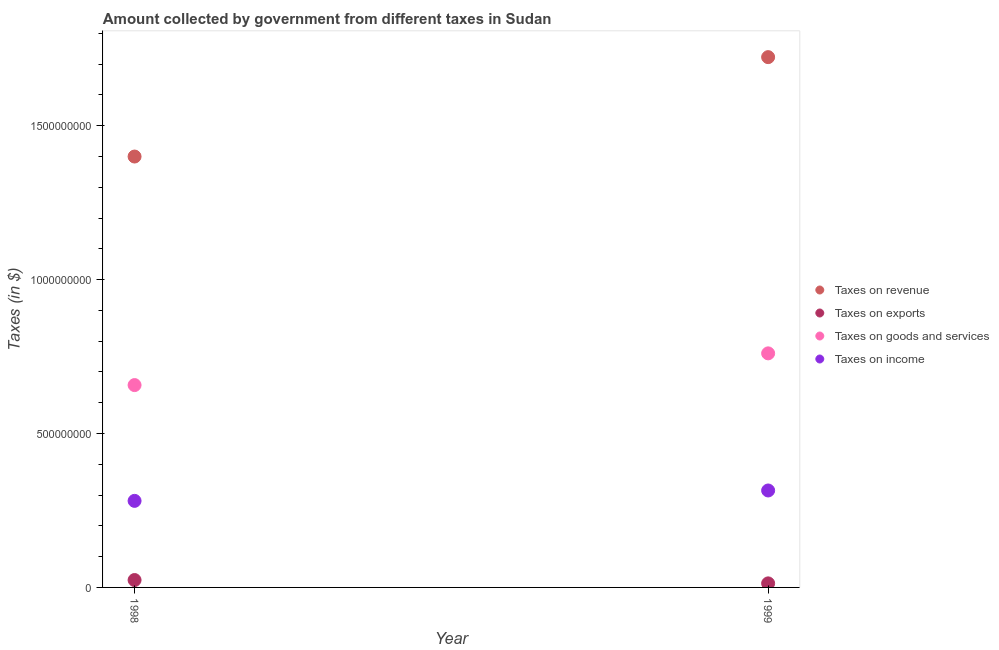Is the number of dotlines equal to the number of legend labels?
Offer a terse response. Yes. What is the amount collected as tax on exports in 1999?
Offer a terse response. 1.32e+07. Across all years, what is the maximum amount collected as tax on goods?
Your response must be concise. 7.60e+08. Across all years, what is the minimum amount collected as tax on exports?
Your answer should be very brief. 1.32e+07. In which year was the amount collected as tax on exports minimum?
Provide a succinct answer. 1999. What is the total amount collected as tax on income in the graph?
Your answer should be compact. 5.96e+08. What is the difference between the amount collected as tax on income in 1998 and that in 1999?
Offer a very short reply. -3.38e+07. What is the difference between the amount collected as tax on goods in 1999 and the amount collected as tax on exports in 1998?
Offer a terse response. 7.36e+08. What is the average amount collected as tax on goods per year?
Give a very brief answer. 7.09e+08. In the year 1998, what is the difference between the amount collected as tax on revenue and amount collected as tax on goods?
Provide a succinct answer. 7.43e+08. In how many years, is the amount collected as tax on income greater than 800000000 $?
Offer a terse response. 0. What is the ratio of the amount collected as tax on goods in 1998 to that in 1999?
Give a very brief answer. 0.86. Is the amount collected as tax on goods in 1998 less than that in 1999?
Your answer should be very brief. Yes. Is it the case that in every year, the sum of the amount collected as tax on exports and amount collected as tax on income is greater than the sum of amount collected as tax on revenue and amount collected as tax on goods?
Provide a short and direct response. No. Does the amount collected as tax on exports monotonically increase over the years?
Make the answer very short. No. How many years are there in the graph?
Provide a short and direct response. 2. What is the difference between two consecutive major ticks on the Y-axis?
Your answer should be compact. 5.00e+08. Are the values on the major ticks of Y-axis written in scientific E-notation?
Offer a terse response. No. Does the graph contain any zero values?
Ensure brevity in your answer.  No. Does the graph contain grids?
Give a very brief answer. No. Where does the legend appear in the graph?
Your answer should be compact. Center right. How many legend labels are there?
Keep it short and to the point. 4. What is the title of the graph?
Make the answer very short. Amount collected by government from different taxes in Sudan. Does "Public resource use" appear as one of the legend labels in the graph?
Your answer should be compact. No. What is the label or title of the X-axis?
Keep it short and to the point. Year. What is the label or title of the Y-axis?
Keep it short and to the point. Taxes (in $). What is the Taxes (in $) of Taxes on revenue in 1998?
Make the answer very short. 1.40e+09. What is the Taxes (in $) of Taxes on exports in 1998?
Offer a very short reply. 2.40e+07. What is the Taxes (in $) in Taxes on goods and services in 1998?
Provide a succinct answer. 6.57e+08. What is the Taxes (in $) in Taxes on income in 1998?
Your response must be concise. 2.81e+08. What is the Taxes (in $) of Taxes on revenue in 1999?
Your response must be concise. 1.72e+09. What is the Taxes (in $) of Taxes on exports in 1999?
Make the answer very short. 1.32e+07. What is the Taxes (in $) in Taxes on goods and services in 1999?
Offer a terse response. 7.60e+08. What is the Taxes (in $) of Taxes on income in 1999?
Ensure brevity in your answer.  3.15e+08. Across all years, what is the maximum Taxes (in $) of Taxes on revenue?
Keep it short and to the point. 1.72e+09. Across all years, what is the maximum Taxes (in $) in Taxes on exports?
Make the answer very short. 2.40e+07. Across all years, what is the maximum Taxes (in $) in Taxes on goods and services?
Give a very brief answer. 7.60e+08. Across all years, what is the maximum Taxes (in $) of Taxes on income?
Your answer should be very brief. 3.15e+08. Across all years, what is the minimum Taxes (in $) in Taxes on revenue?
Your response must be concise. 1.40e+09. Across all years, what is the minimum Taxes (in $) of Taxes on exports?
Ensure brevity in your answer.  1.32e+07. Across all years, what is the minimum Taxes (in $) of Taxes on goods and services?
Make the answer very short. 6.57e+08. Across all years, what is the minimum Taxes (in $) in Taxes on income?
Your response must be concise. 2.81e+08. What is the total Taxes (in $) of Taxes on revenue in the graph?
Provide a succinct answer. 3.12e+09. What is the total Taxes (in $) of Taxes on exports in the graph?
Make the answer very short. 3.72e+07. What is the total Taxes (in $) of Taxes on goods and services in the graph?
Keep it short and to the point. 1.42e+09. What is the total Taxes (in $) in Taxes on income in the graph?
Ensure brevity in your answer.  5.96e+08. What is the difference between the Taxes (in $) in Taxes on revenue in 1998 and that in 1999?
Ensure brevity in your answer.  -3.23e+08. What is the difference between the Taxes (in $) in Taxes on exports in 1998 and that in 1999?
Make the answer very short. 1.08e+07. What is the difference between the Taxes (in $) of Taxes on goods and services in 1998 and that in 1999?
Give a very brief answer. -1.03e+08. What is the difference between the Taxes (in $) of Taxes on income in 1998 and that in 1999?
Your answer should be compact. -3.38e+07. What is the difference between the Taxes (in $) of Taxes on revenue in 1998 and the Taxes (in $) of Taxes on exports in 1999?
Your answer should be very brief. 1.39e+09. What is the difference between the Taxes (in $) in Taxes on revenue in 1998 and the Taxes (in $) in Taxes on goods and services in 1999?
Your answer should be compact. 6.39e+08. What is the difference between the Taxes (in $) in Taxes on revenue in 1998 and the Taxes (in $) in Taxes on income in 1999?
Provide a short and direct response. 1.08e+09. What is the difference between the Taxes (in $) in Taxes on exports in 1998 and the Taxes (in $) in Taxes on goods and services in 1999?
Give a very brief answer. -7.36e+08. What is the difference between the Taxes (in $) of Taxes on exports in 1998 and the Taxes (in $) of Taxes on income in 1999?
Give a very brief answer. -2.91e+08. What is the difference between the Taxes (in $) in Taxes on goods and services in 1998 and the Taxes (in $) in Taxes on income in 1999?
Offer a terse response. 3.42e+08. What is the average Taxes (in $) in Taxes on revenue per year?
Make the answer very short. 1.56e+09. What is the average Taxes (in $) of Taxes on exports per year?
Keep it short and to the point. 1.86e+07. What is the average Taxes (in $) in Taxes on goods and services per year?
Give a very brief answer. 7.09e+08. What is the average Taxes (in $) in Taxes on income per year?
Your answer should be very brief. 2.98e+08. In the year 1998, what is the difference between the Taxes (in $) in Taxes on revenue and Taxes (in $) in Taxes on exports?
Provide a succinct answer. 1.38e+09. In the year 1998, what is the difference between the Taxes (in $) of Taxes on revenue and Taxes (in $) of Taxes on goods and services?
Provide a short and direct response. 7.43e+08. In the year 1998, what is the difference between the Taxes (in $) of Taxes on revenue and Taxes (in $) of Taxes on income?
Give a very brief answer. 1.12e+09. In the year 1998, what is the difference between the Taxes (in $) in Taxes on exports and Taxes (in $) in Taxes on goods and services?
Offer a terse response. -6.33e+08. In the year 1998, what is the difference between the Taxes (in $) of Taxes on exports and Taxes (in $) of Taxes on income?
Offer a very short reply. -2.57e+08. In the year 1998, what is the difference between the Taxes (in $) in Taxes on goods and services and Taxes (in $) in Taxes on income?
Give a very brief answer. 3.76e+08. In the year 1999, what is the difference between the Taxes (in $) in Taxes on revenue and Taxes (in $) in Taxes on exports?
Offer a very short reply. 1.71e+09. In the year 1999, what is the difference between the Taxes (in $) in Taxes on revenue and Taxes (in $) in Taxes on goods and services?
Give a very brief answer. 9.62e+08. In the year 1999, what is the difference between the Taxes (in $) of Taxes on revenue and Taxes (in $) of Taxes on income?
Your answer should be very brief. 1.41e+09. In the year 1999, what is the difference between the Taxes (in $) in Taxes on exports and Taxes (in $) in Taxes on goods and services?
Provide a short and direct response. -7.47e+08. In the year 1999, what is the difference between the Taxes (in $) in Taxes on exports and Taxes (in $) in Taxes on income?
Your answer should be very brief. -3.02e+08. In the year 1999, what is the difference between the Taxes (in $) in Taxes on goods and services and Taxes (in $) in Taxes on income?
Provide a succinct answer. 4.46e+08. What is the ratio of the Taxes (in $) in Taxes on revenue in 1998 to that in 1999?
Your answer should be compact. 0.81. What is the ratio of the Taxes (in $) of Taxes on exports in 1998 to that in 1999?
Your answer should be compact. 1.82. What is the ratio of the Taxes (in $) of Taxes on goods and services in 1998 to that in 1999?
Offer a terse response. 0.86. What is the ratio of the Taxes (in $) in Taxes on income in 1998 to that in 1999?
Give a very brief answer. 0.89. What is the difference between the highest and the second highest Taxes (in $) of Taxes on revenue?
Your answer should be very brief. 3.23e+08. What is the difference between the highest and the second highest Taxes (in $) of Taxes on exports?
Make the answer very short. 1.08e+07. What is the difference between the highest and the second highest Taxes (in $) in Taxes on goods and services?
Your response must be concise. 1.03e+08. What is the difference between the highest and the second highest Taxes (in $) of Taxes on income?
Your response must be concise. 3.38e+07. What is the difference between the highest and the lowest Taxes (in $) of Taxes on revenue?
Make the answer very short. 3.23e+08. What is the difference between the highest and the lowest Taxes (in $) in Taxes on exports?
Give a very brief answer. 1.08e+07. What is the difference between the highest and the lowest Taxes (in $) of Taxes on goods and services?
Keep it short and to the point. 1.03e+08. What is the difference between the highest and the lowest Taxes (in $) of Taxes on income?
Give a very brief answer. 3.38e+07. 